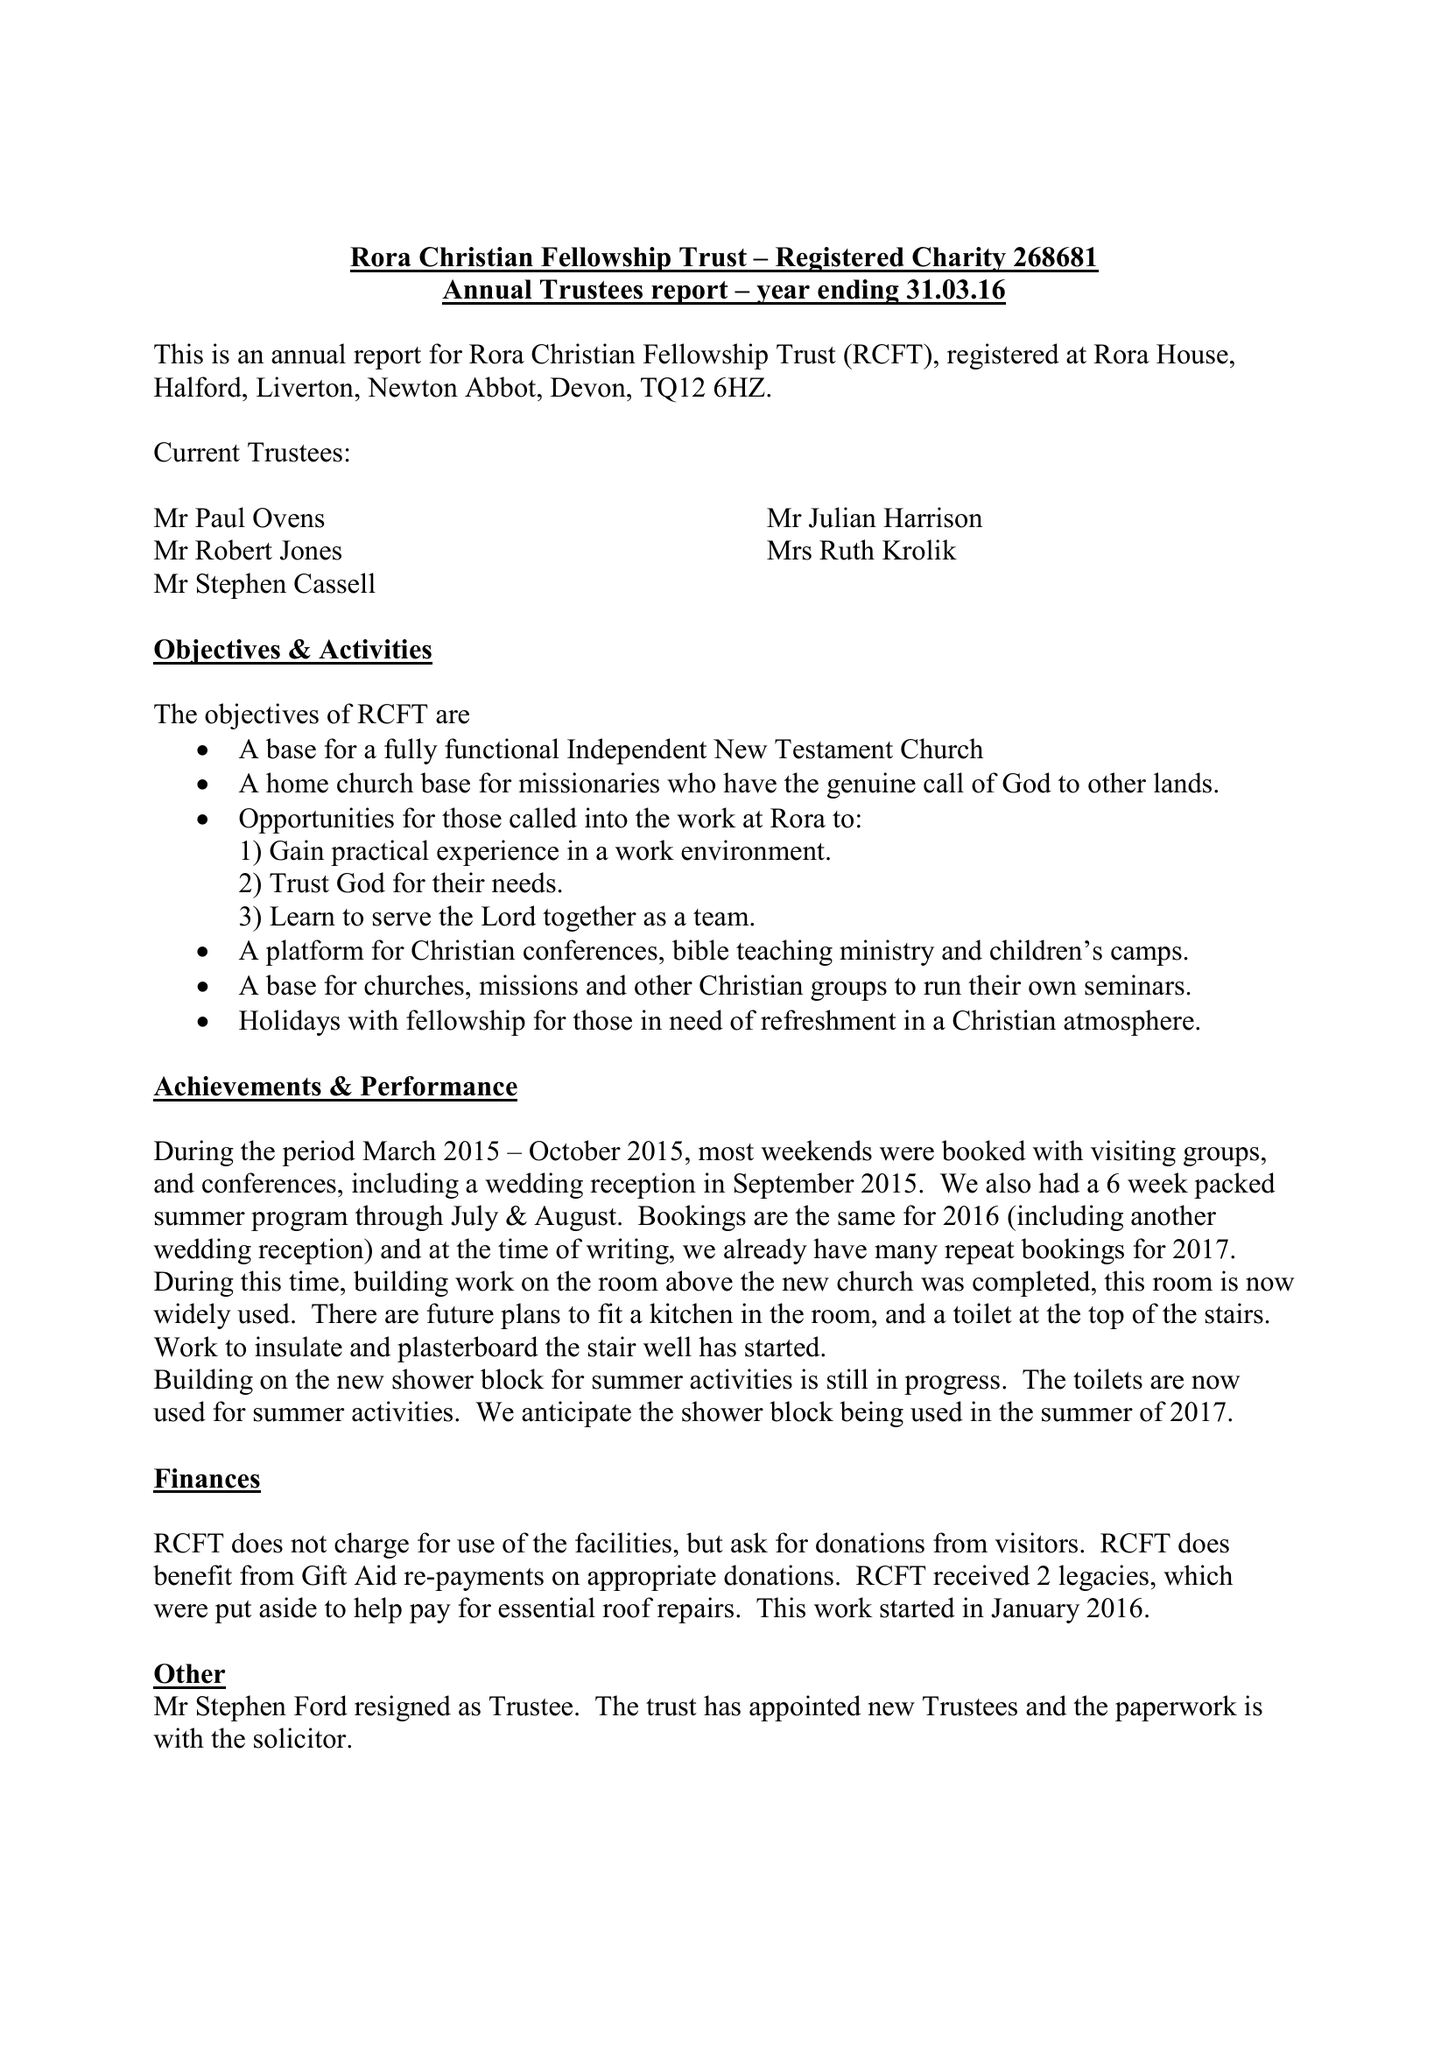What is the value for the charity_name?
Answer the question using a single word or phrase. The Rora Christian Fellowship 